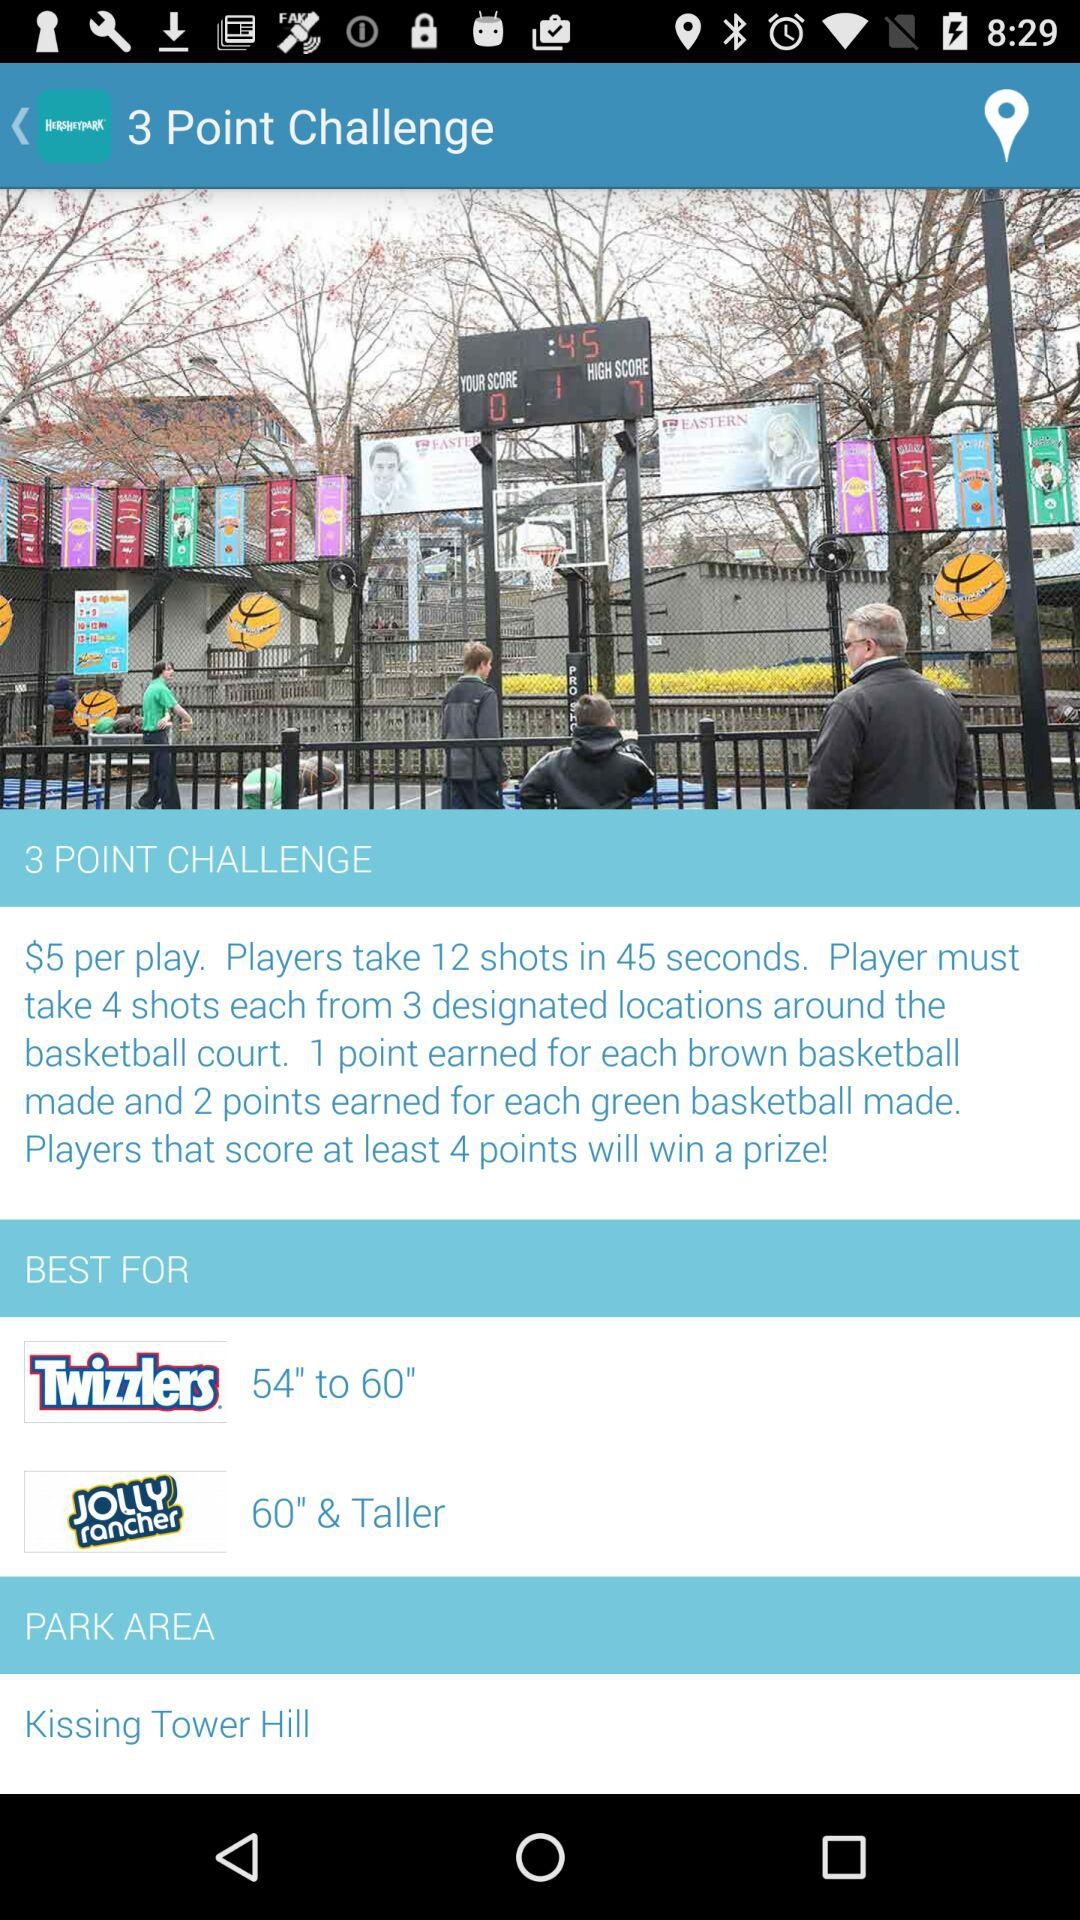How many items are in the best for section?
Answer the question using a single word or phrase. 2 